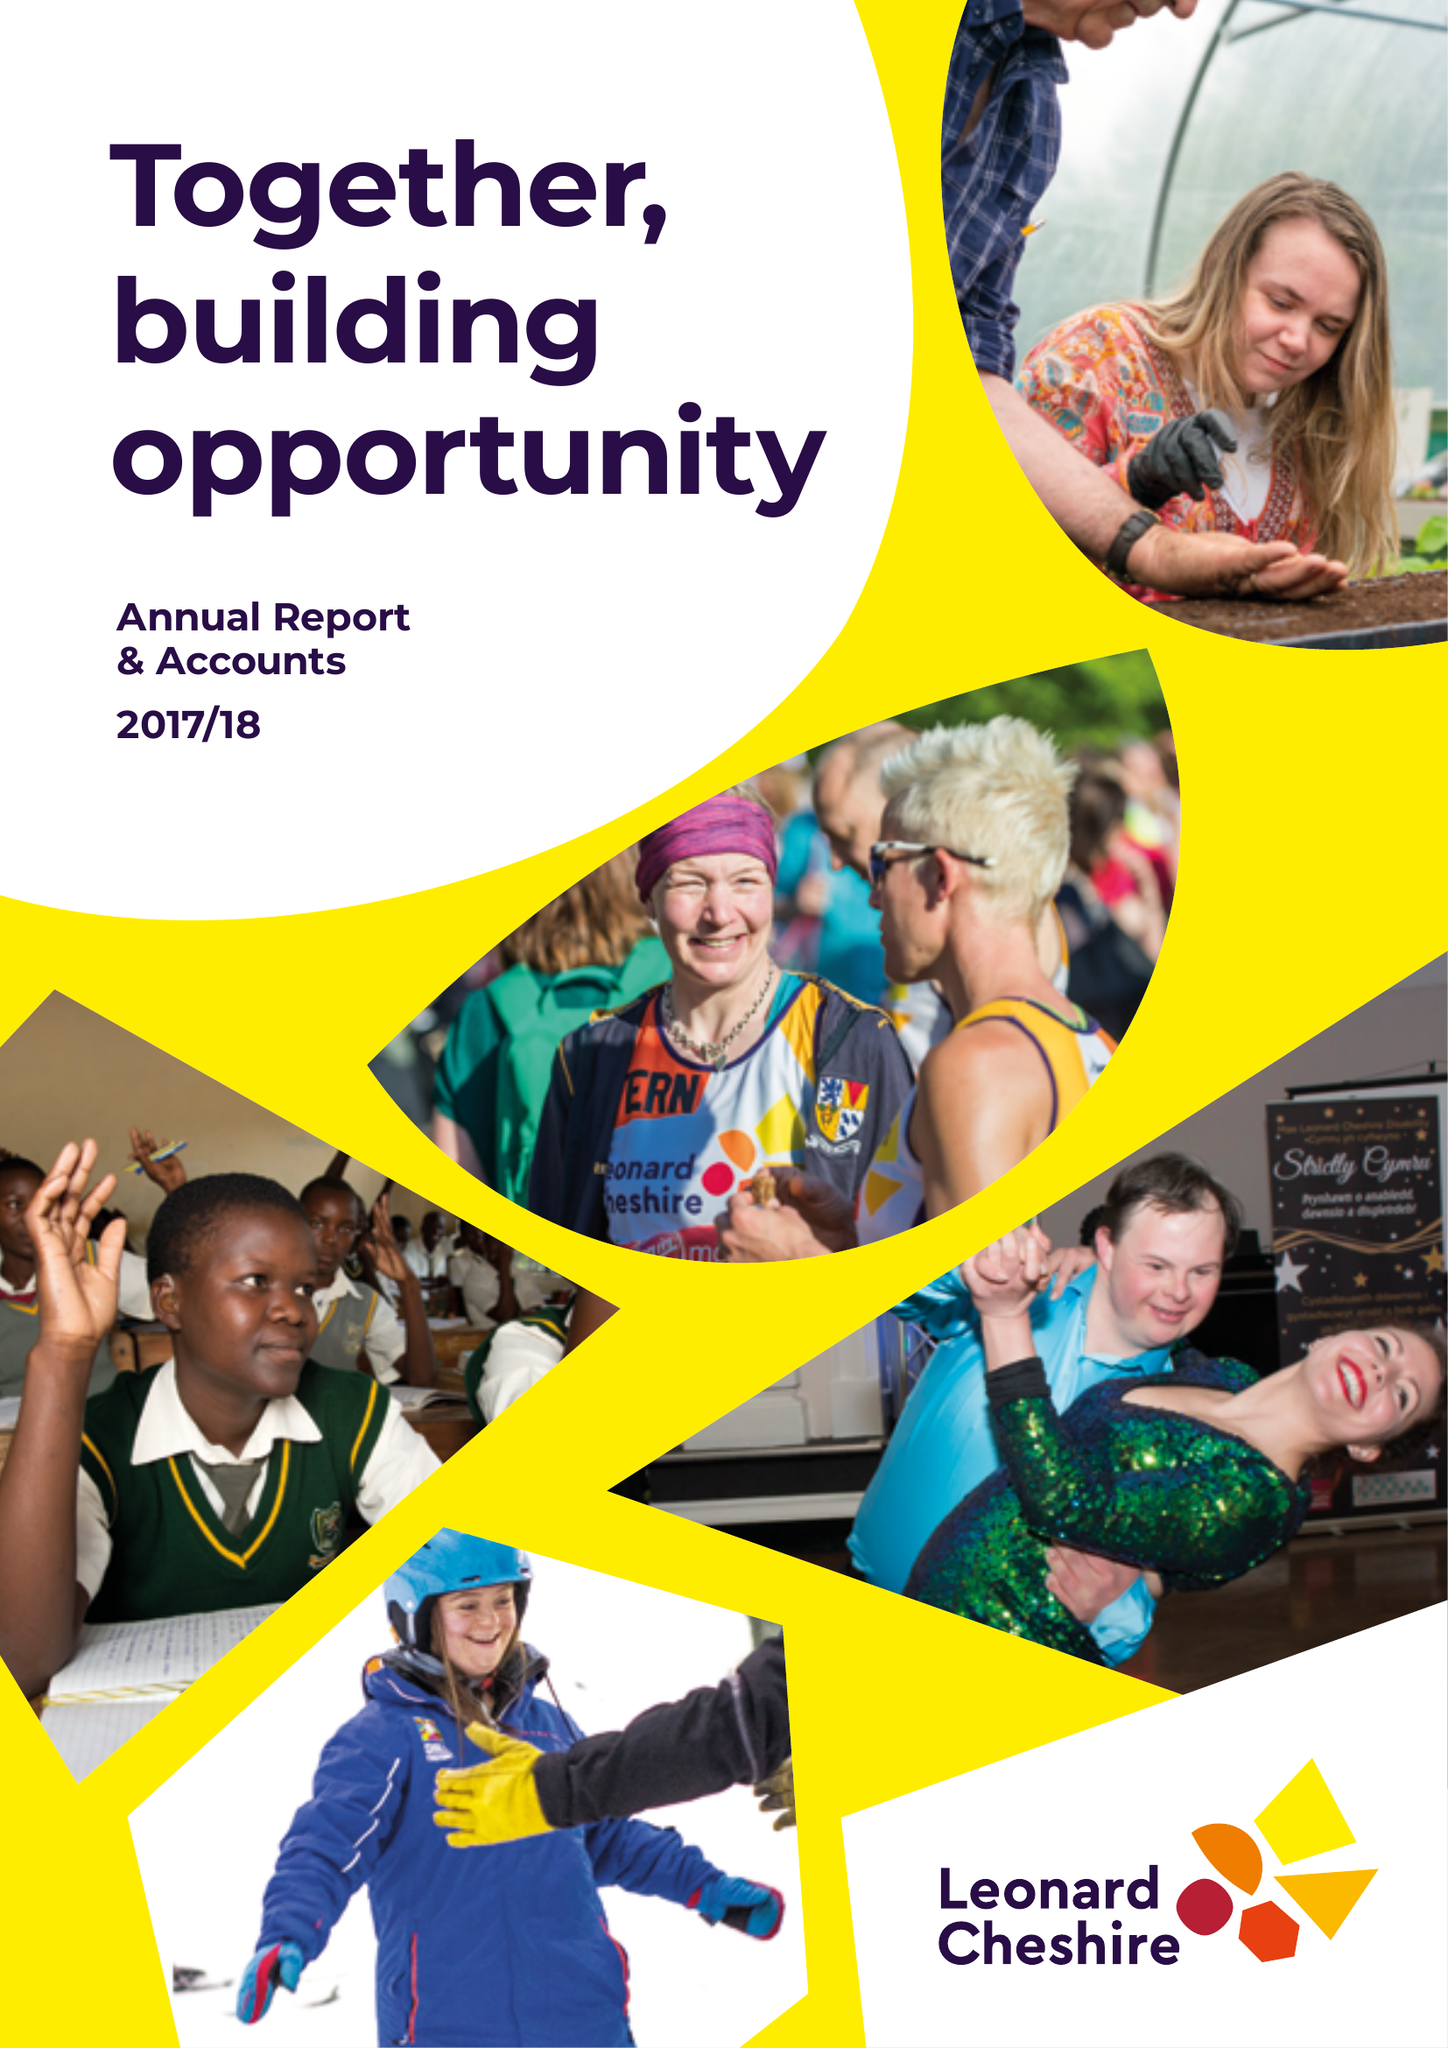What is the value for the address__street_line?
Answer the question using a single word or phrase. 66 SOUTH LAMBETH ROAD 